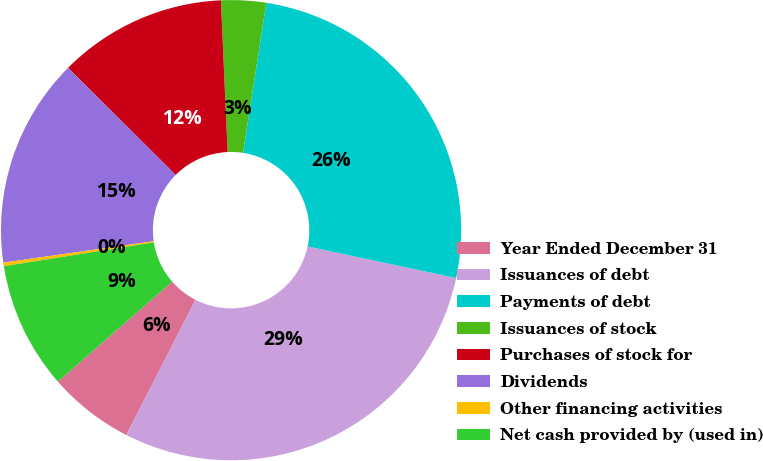<chart> <loc_0><loc_0><loc_500><loc_500><pie_chart><fcel>Year Ended December 31<fcel>Issuances of debt<fcel>Payments of debt<fcel>Issuances of stock<fcel>Purchases of stock for<fcel>Dividends<fcel>Other financing activities<fcel>Net cash provided by (used in)<nl><fcel>6.04%<fcel>29.19%<fcel>25.89%<fcel>3.15%<fcel>11.83%<fcel>14.72%<fcel>0.25%<fcel>8.93%<nl></chart> 